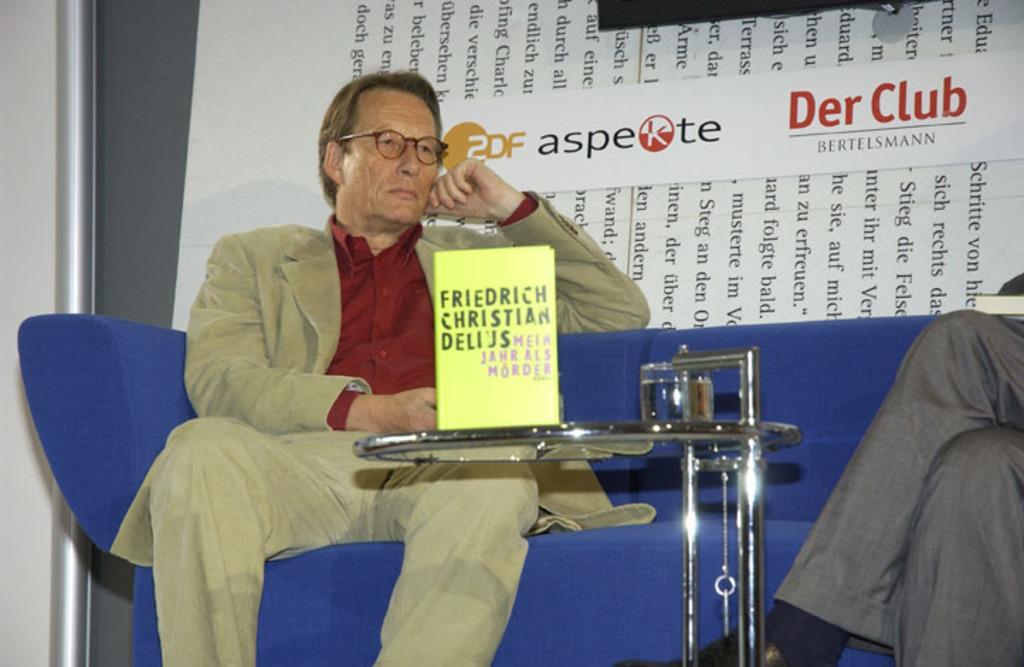In one or two sentences, can you explain what this image depicts? In this picture we can observe a man sitting in the blue color sofa, wearing a coat and spectacles. In front of him there is a glass table on which we can observe yellow color board on it. On the right side there is another person sitting. In the background we can observe some words on the white color background. 